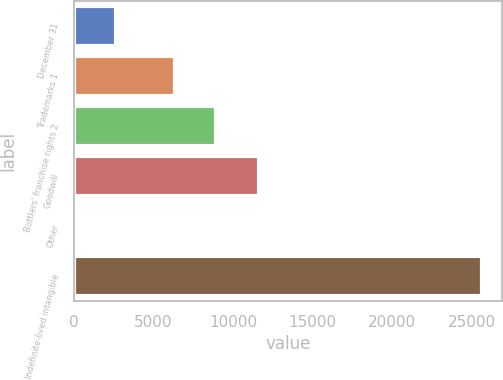Convert chart. <chart><loc_0><loc_0><loc_500><loc_500><bar_chart><fcel>December 31<fcel>Trademarks 1<fcel>Bottlers' franchise rights 2<fcel>Goodwill<fcel>Other<fcel>Indefinite-lived intangible<nl><fcel>2666.2<fcel>6356<fcel>8909.2<fcel>11665<fcel>113<fcel>25645<nl></chart> 